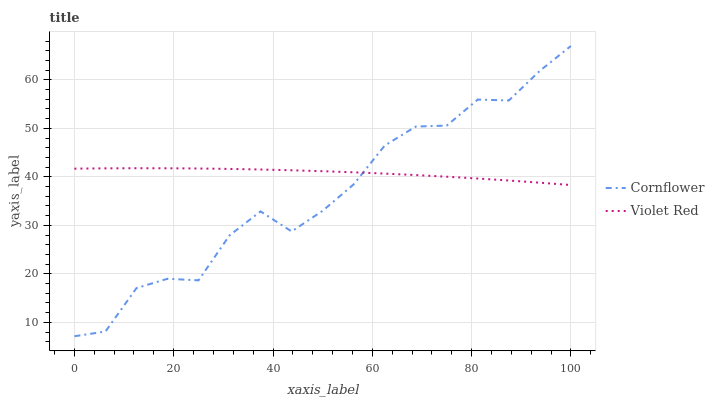Does Violet Red have the minimum area under the curve?
Answer yes or no. No. Is Violet Red the roughest?
Answer yes or no. No. Does Violet Red have the lowest value?
Answer yes or no. No. Does Violet Red have the highest value?
Answer yes or no. No. 